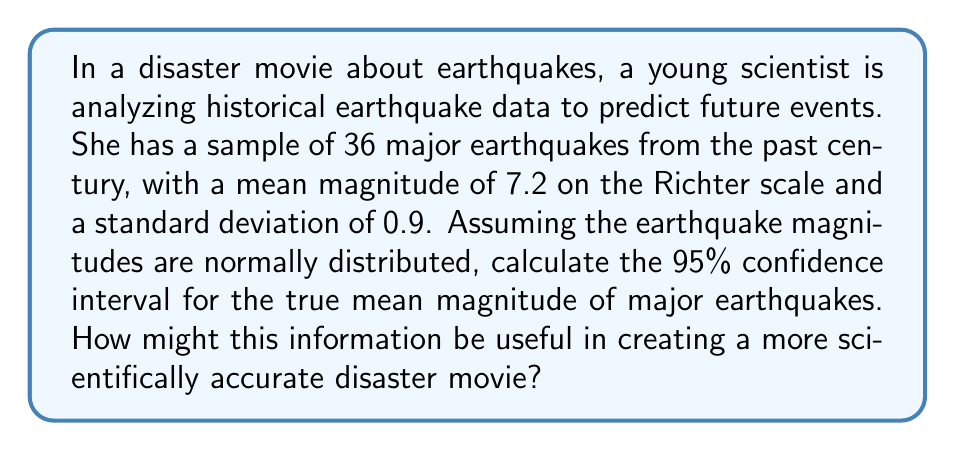Show me your answer to this math problem. Let's approach this step-by-step:

1) We're dealing with a confidence interval for a population mean with unknown population standard deviation. We'll use the t-distribution for this.

2) Given information:
   - Sample size: $n = 36$
   - Sample mean: $\bar{x} = 7.2$
   - Sample standard deviation: $s = 0.9$
   - Confidence level: 95%

3) The formula for the confidence interval is:

   $$\bar{x} \pm t_{\alpha/2, n-1} \cdot \frac{s}{\sqrt{n}}$$

   where $t_{\alpha/2, n-1}$ is the t-value for a 95% confidence interval with $n-1$ degrees of freedom.

4) For a 95% confidence interval, $\alpha = 0.05$, and we have 35 degrees of freedom (n-1 = 35).

5) Looking up the t-value in a t-table or using a calculator, we find:
   $t_{0.025, 35} \approx 2.030$

6) Now we can calculate the margin of error:

   $$2.030 \cdot \frac{0.9}{\sqrt{36}} \approx 0.305$$

7) Therefore, the confidence interval is:

   $$7.2 \pm 0.305$$

   Which gives us the interval (6.895, 7.505)

This information could be used in a disaster movie to add scientific credibility. The scientists in the movie could use this range to predict the likelihood of future earthquakes and their potential magnitudes, adding tension and realism to the plot.
Answer: The 95% confidence interval for the true mean magnitude of major earthquakes is (6.895, 7.505) on the Richter scale. 